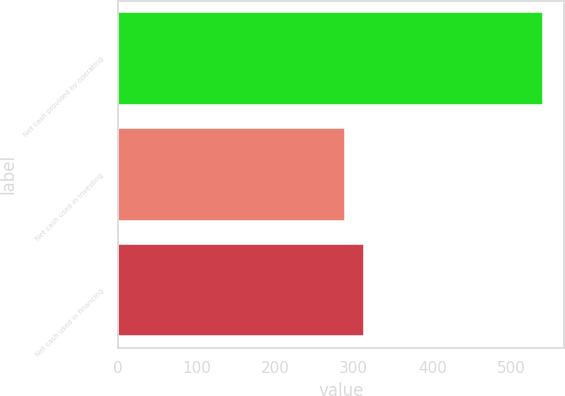<chart> <loc_0><loc_0><loc_500><loc_500><bar_chart><fcel>Net cash provided by operating<fcel>Net cash used in investing<fcel>Net cash used in financing<nl><fcel>540.3<fcel>288.4<fcel>313.59<nl></chart> 